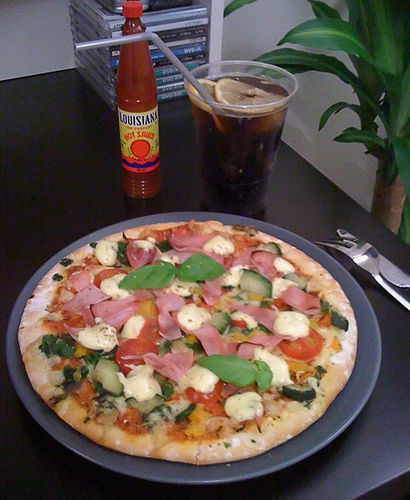Identify and read out the text in this image. LOUISIASA 